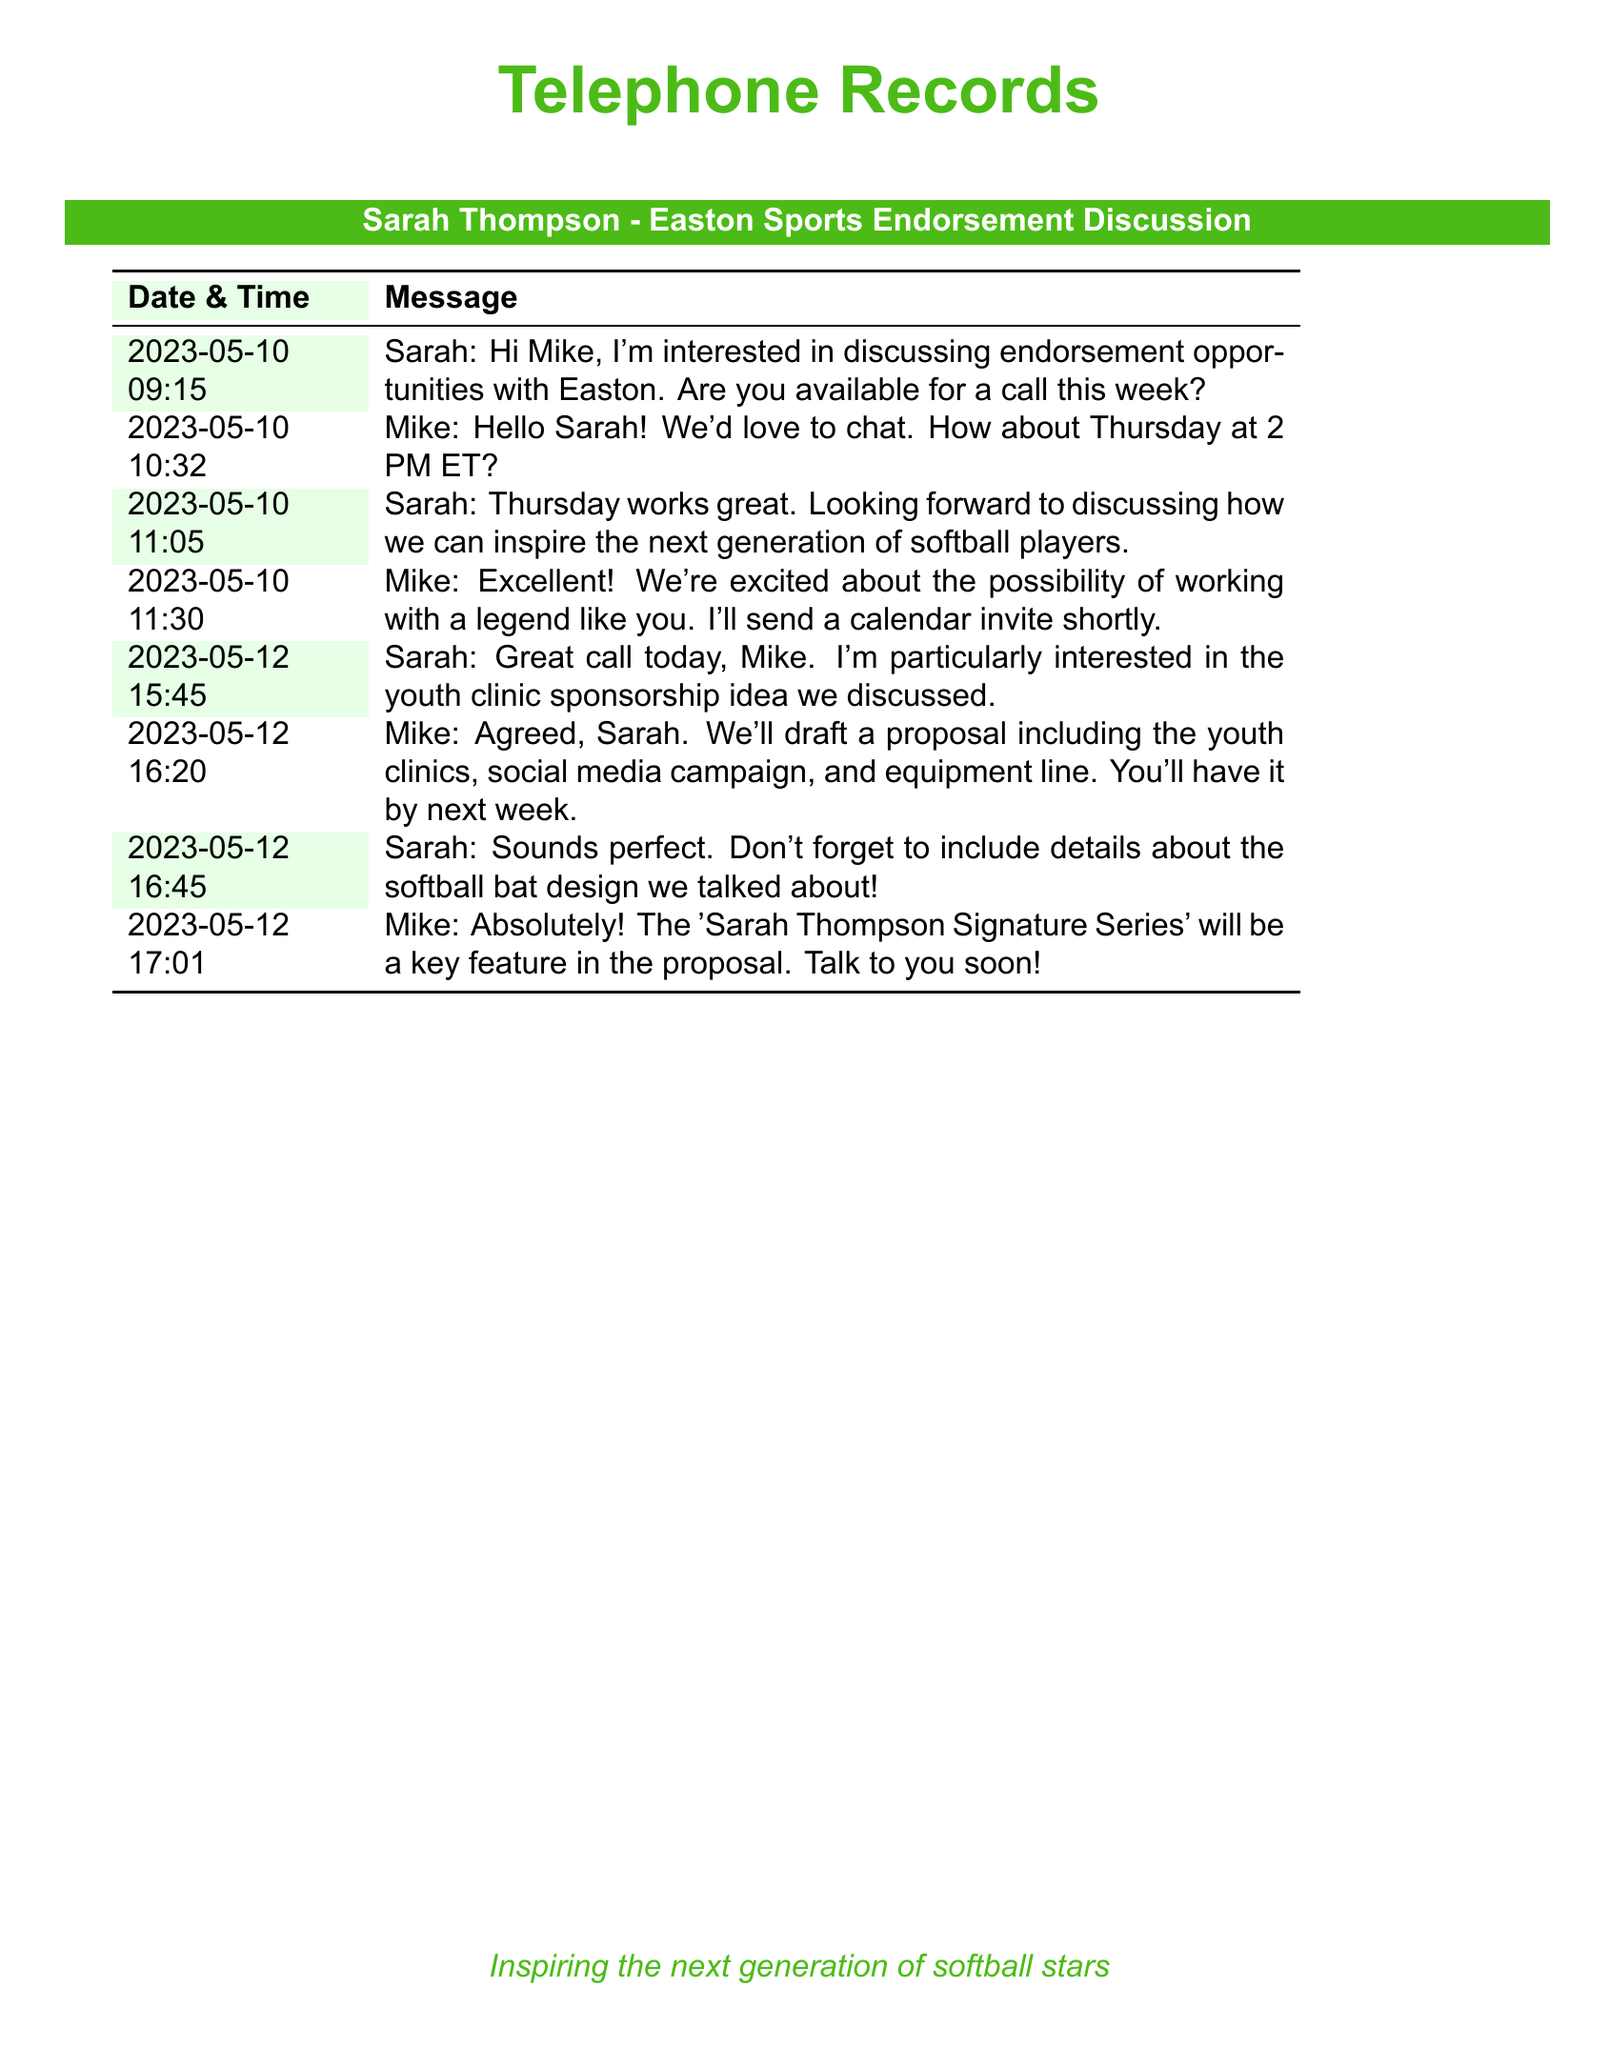What date did Sarah initiate the conversation? The conversation was initiated by Sarah on May 10, 2023, at 09:15 AM.
Answer: May 10, 2023 What time is the scheduled call? The call was scheduled for Thursday at 2 PM ET, as proposed by Mike.
Answer: 2 PM ET What is the name of the equipment line discussed? The equipment line discussed is referred to as the 'Sarah Thompson Signature Series'.
Answer: Sarah Thompson Signature Series Who is the recipient of the messages? The messages are exchanged between Sarah Thompson and Mike from Easton Sports.
Answer: Mike What specific opportunity is Sarah interested in? Sarah expressed particular interest in discussing a youth clinic sponsorship idea.
Answer: youth clinic sponsorship How did Mike describe working with Sarah? Mike described the possibility of working with Sarah as exciting, noting her status as a legend.
Answer: a legend When can Sarah expect to receive the proposal? Mike indicated that the proposal would be sent by the next week following their discussion.
Answer: next week What was one key feature mentioned by Mike for the proposal? Mike mentioned the 'Sarah Thompson Signature Series' as a key feature to include in the proposal.
Answer: Sarah Thompson Signature Series 